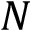Convert formula to latex. <formula><loc_0><loc_0><loc_500><loc_500>N</formula> 